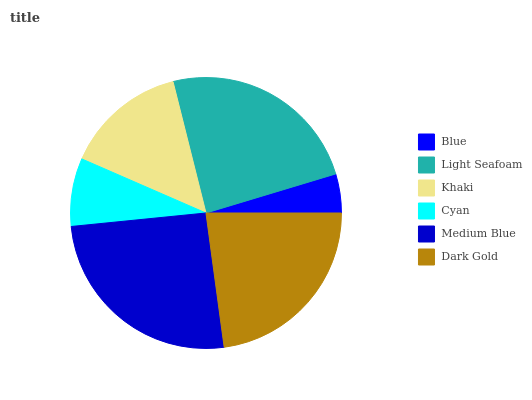Is Blue the minimum?
Answer yes or no. Yes. Is Medium Blue the maximum?
Answer yes or no. Yes. Is Light Seafoam the minimum?
Answer yes or no. No. Is Light Seafoam the maximum?
Answer yes or no. No. Is Light Seafoam greater than Blue?
Answer yes or no. Yes. Is Blue less than Light Seafoam?
Answer yes or no. Yes. Is Blue greater than Light Seafoam?
Answer yes or no. No. Is Light Seafoam less than Blue?
Answer yes or no. No. Is Dark Gold the high median?
Answer yes or no. Yes. Is Khaki the low median?
Answer yes or no. Yes. Is Light Seafoam the high median?
Answer yes or no. No. Is Light Seafoam the low median?
Answer yes or no. No. 